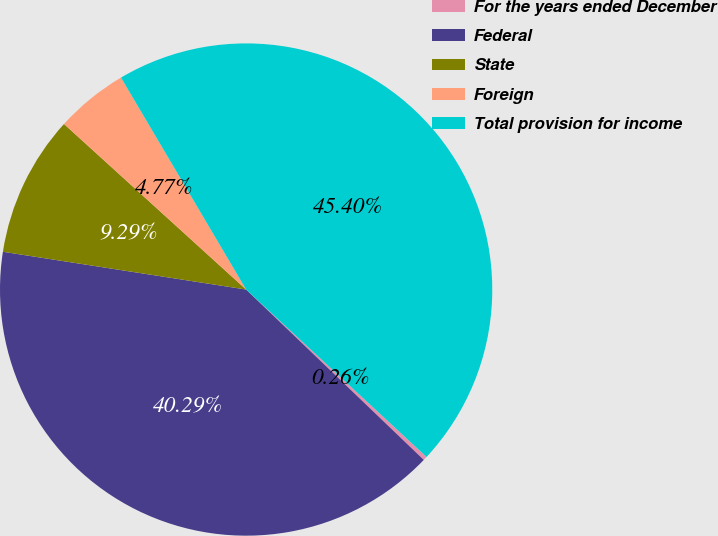Convert chart to OTSL. <chart><loc_0><loc_0><loc_500><loc_500><pie_chart><fcel>For the years ended December<fcel>Federal<fcel>State<fcel>Foreign<fcel>Total provision for income<nl><fcel>0.26%<fcel>40.29%<fcel>9.29%<fcel>4.77%<fcel>45.4%<nl></chart> 